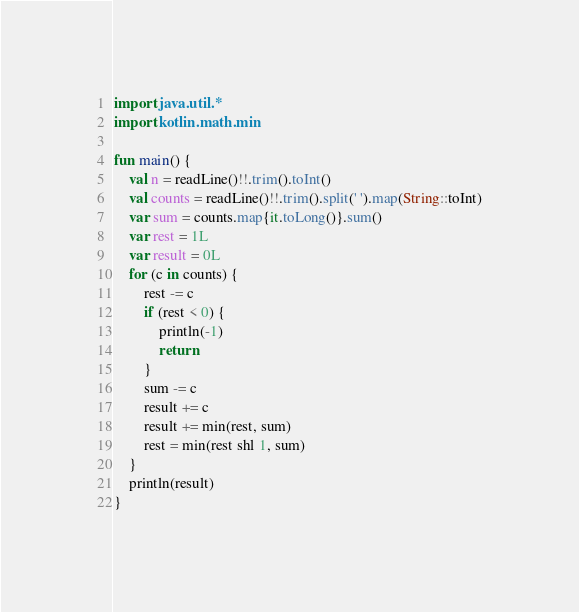Convert code to text. <code><loc_0><loc_0><loc_500><loc_500><_Kotlin_>import java.util.*
import kotlin.math.min

fun main() {
    val n = readLine()!!.trim().toInt()
    val counts = readLine()!!.trim().split(' ').map(String::toInt)
    var sum = counts.map{it.toLong()}.sum()
    var rest = 1L
    var result = 0L
    for (c in counts) {
        rest -= c
        if (rest < 0) {
            println(-1)
            return
        }
        sum -= c
        result += c
        result += min(rest, sum)
        rest = min(rest shl 1, sum)
    }
    println(result)
}</code> 